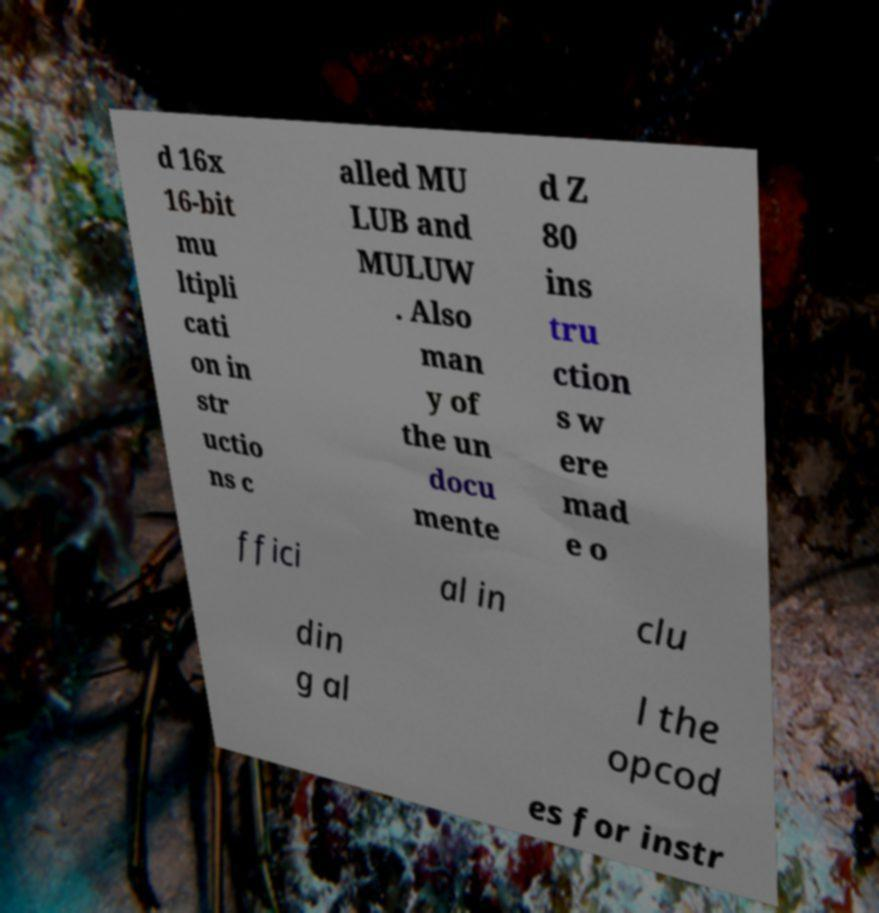Could you assist in decoding the text presented in this image and type it out clearly? d 16x 16-bit mu ltipli cati on in str uctio ns c alled MU LUB and MULUW . Also man y of the un docu mente d Z 80 ins tru ction s w ere mad e o ffici al in clu din g al l the opcod es for instr 